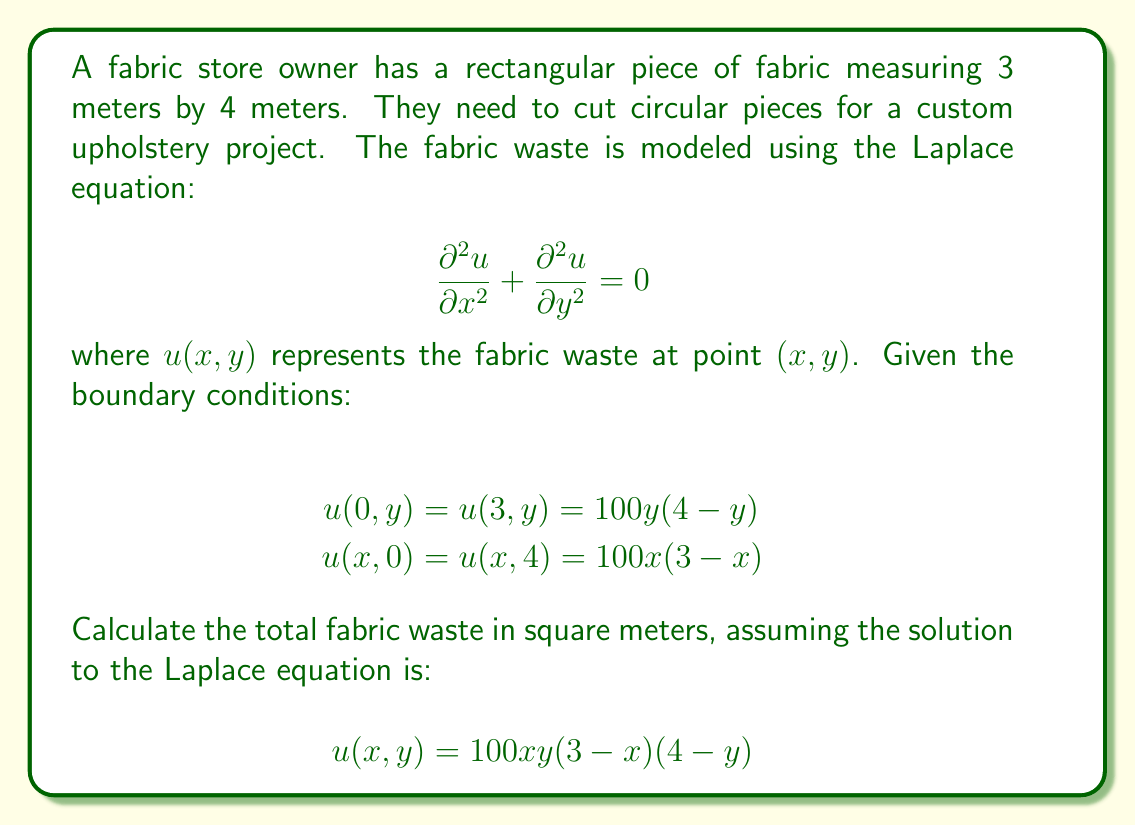Can you answer this question? To solve this problem, we need to follow these steps:

1. Verify that the given solution satisfies the Laplace equation.
2. Confirm that the solution meets the boundary conditions.
3. Integrate the solution over the entire fabric area to calculate the total waste.

Step 1: Verify the solution
Let's calculate the partial derivatives:

$$\frac{\partial u}{\partial x} = 100y(3-x)(4-y) - 100xy(4-y)$$
$$\frac{\partial^2 u}{\partial x^2} = -200y(4-y)$$

$$\frac{\partial u}{\partial y} = 100x(3-x)(4-y) - 100xy(3-x)$$
$$\frac{\partial^2 u}{\partial y^2} = -200x(3-x)$$

Now, let's substitute these into the Laplace equation:

$$\frac{\partial^2 u}{\partial x^2} + \frac{\partial^2 u}{\partial y^2} = -200y(4-y) - 200x(3-x) = 0$$

This confirms that the given solution satisfies the Laplace equation.

Step 2: Verify boundary conditions
At $x = 0$ and $x = 3$:
$$u(0,y) = u(3,y) = 100y(4-y)$$

At $y = 0$ and $y = 4$:
$$u(x,0) = u(x,4) = 100x(3-x)$$

These match the given boundary conditions.

Step 3: Calculate total waste
To find the total waste, we need to integrate the solution over the entire fabric area:

$$\text{Total Waste} = \int_0^3 \int_0^4 u(x,y) \, dy \, dx$$

$$= \int_0^3 \int_0^4 100xy(3-x)(4-y) \, dy \, dx$$

$$= 100 \int_0^3 x(3-x) \left[ \int_0^4 y(4-y) \, dy \right] \, dx$$

$$= 100 \int_0^3 x(3-x) \left[ \frac{4y^2}{2} - \frac{y^3}{3} \right]_0^4 \, dx$$

$$= 100 \int_0^3 x(3-x) \cdot \frac{32}{3} \, dx$$

$$= \frac{3200}{3} \int_0^3 (3x - x^2) \, dx$$

$$= \frac{3200}{3} \left[ \frac{3x^2}{2} - \frac{x^3}{3} \right]_0^3$$

$$= \frac{3200}{3} \left( \frac{27}{2} - 9 \right)$$

$$= \frac{3200}{3} \cdot \frac{9}{2} = 4800$$
Answer: The total fabric waste is 4.8 square meters. 